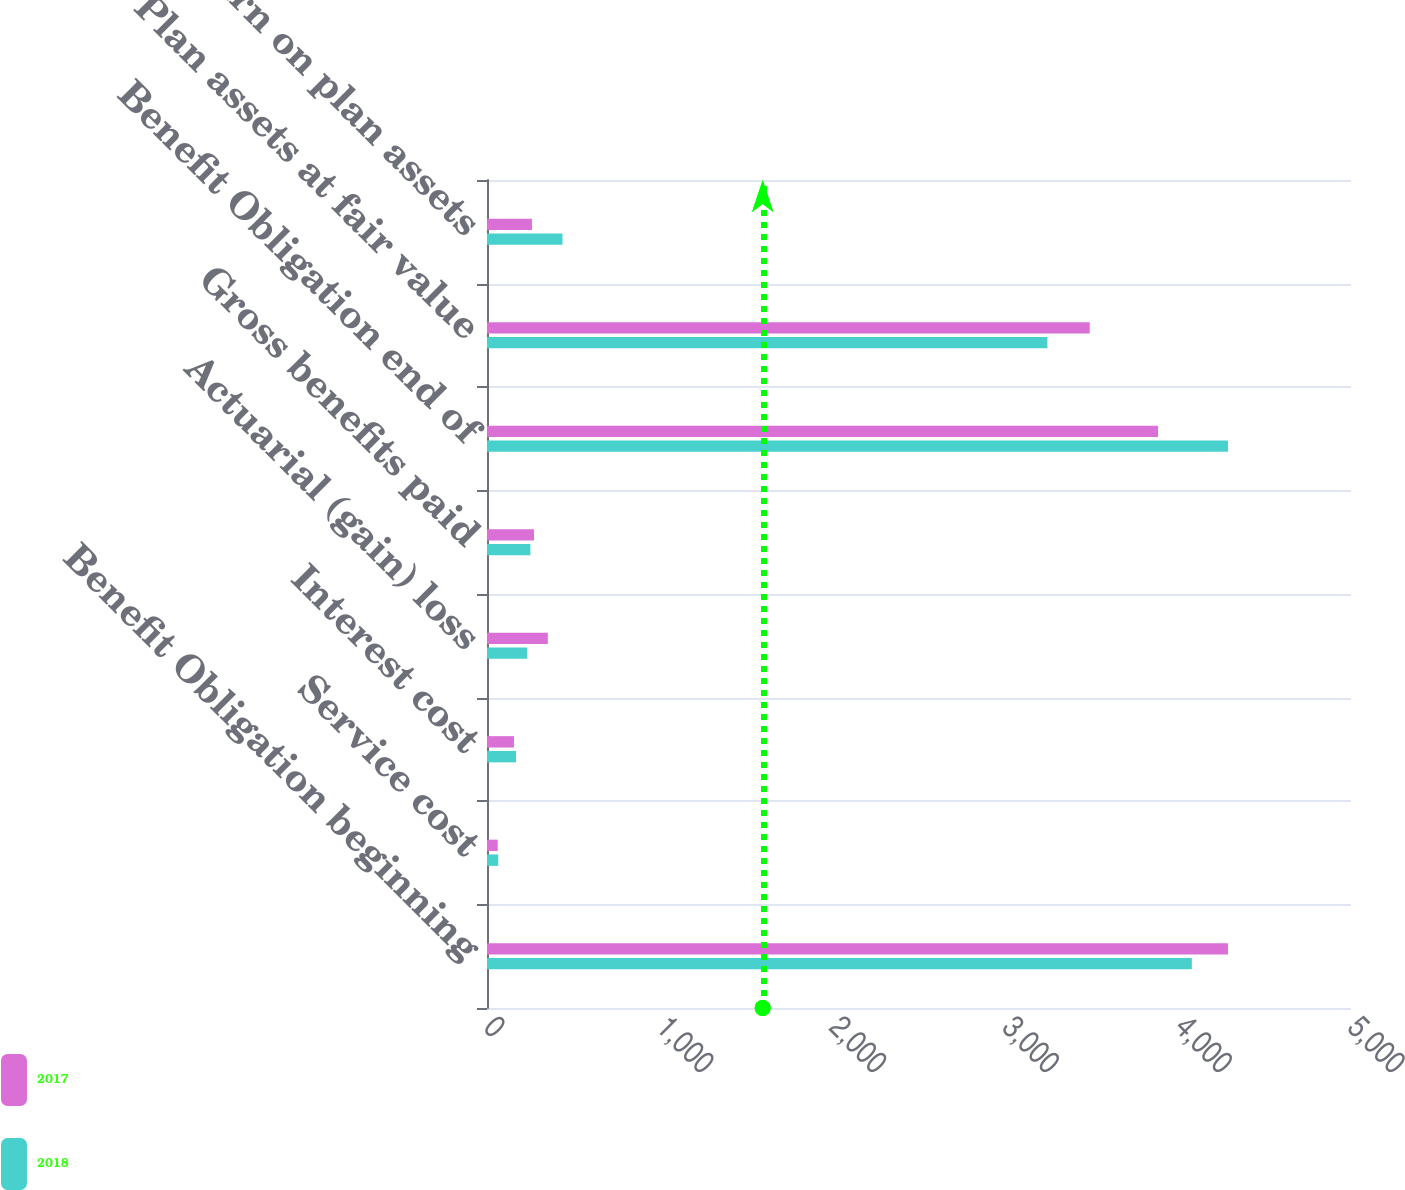<chart> <loc_0><loc_0><loc_500><loc_500><stacked_bar_chart><ecel><fcel>Benefit Obligation beginning<fcel>Service cost<fcel>Interest cost<fcel>Actuarial (gain) loss<fcel>Gross benefits paid<fcel>Benefit Obligation end of<fcel>Plan assets at fair value<fcel>Actual return on plan assets<nl><fcel>2017<fcel>4288<fcel>62<fcel>156<fcel>352<fcel>272<fcel>3883<fcel>3488<fcel>260<nl><fcel>2018<fcel>4079<fcel>65<fcel>168<fcel>233<fcel>251<fcel>4288<fcel>3243<fcel>437<nl></chart> 